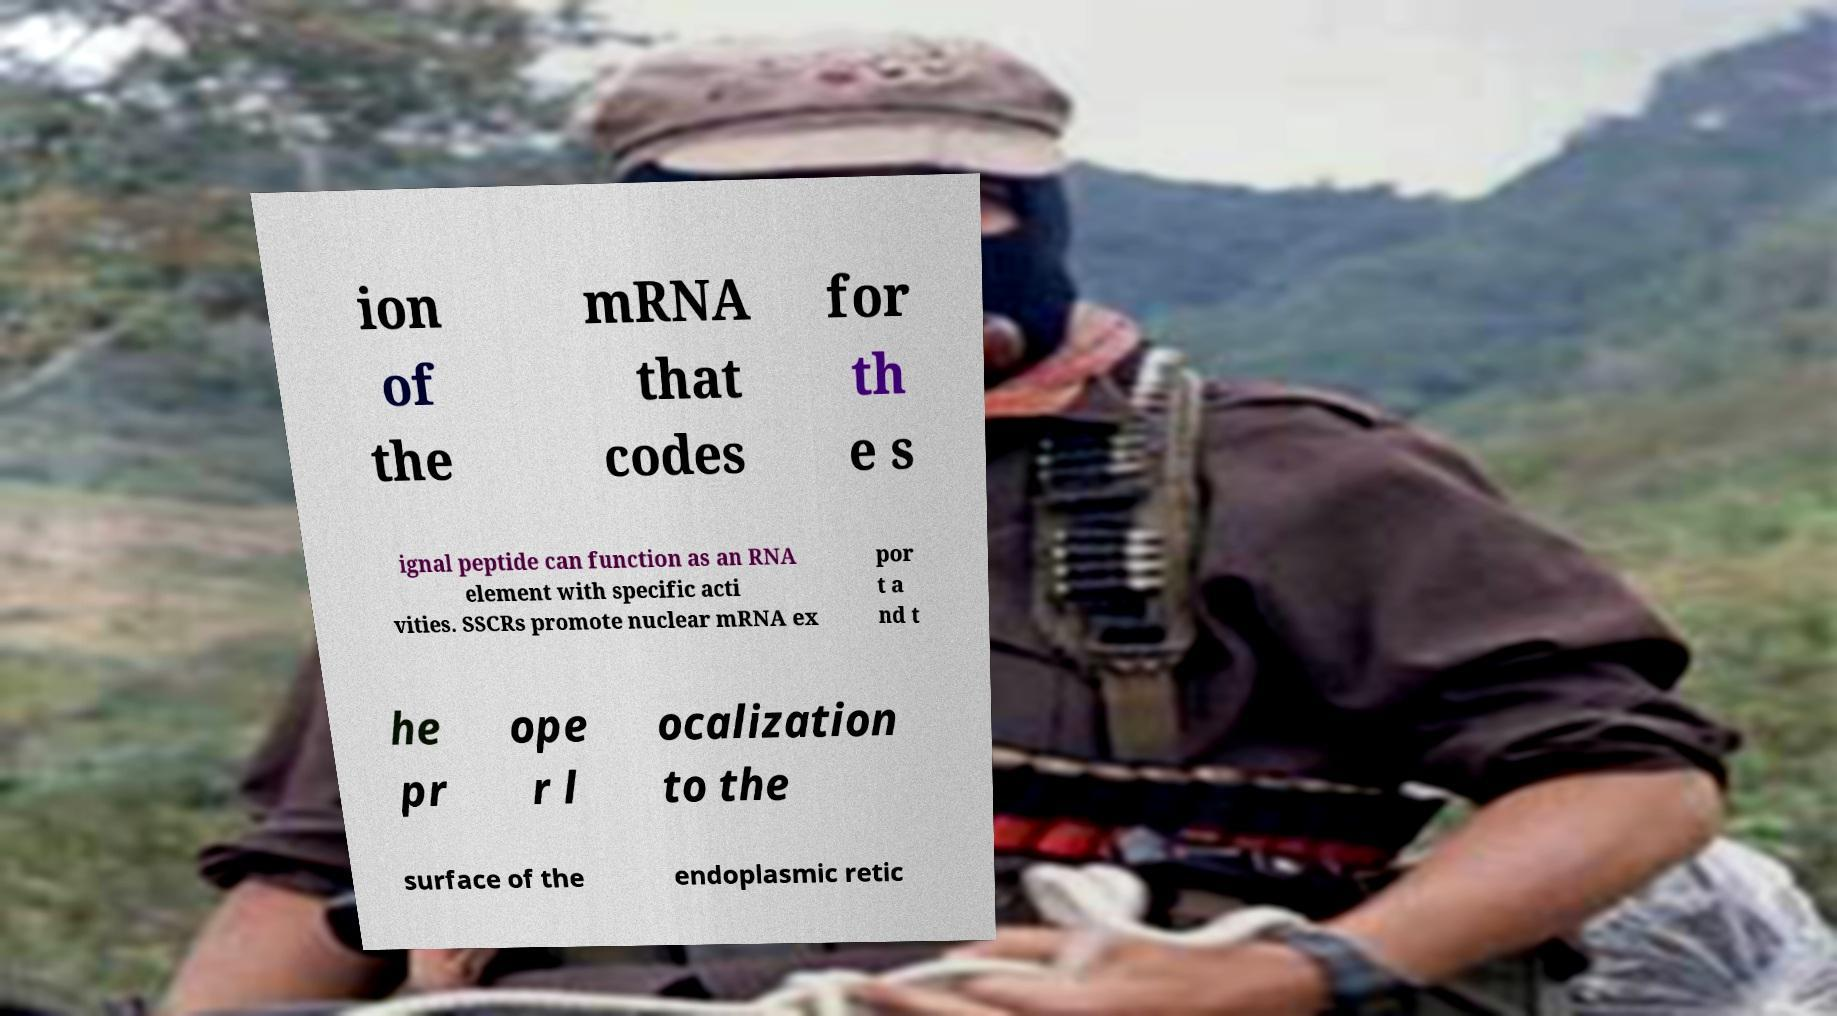Please read and relay the text visible in this image. What does it say? ion of the mRNA that codes for th e s ignal peptide can function as an RNA element with specific acti vities. SSCRs promote nuclear mRNA ex por t a nd t he pr ope r l ocalization to the surface of the endoplasmic retic 